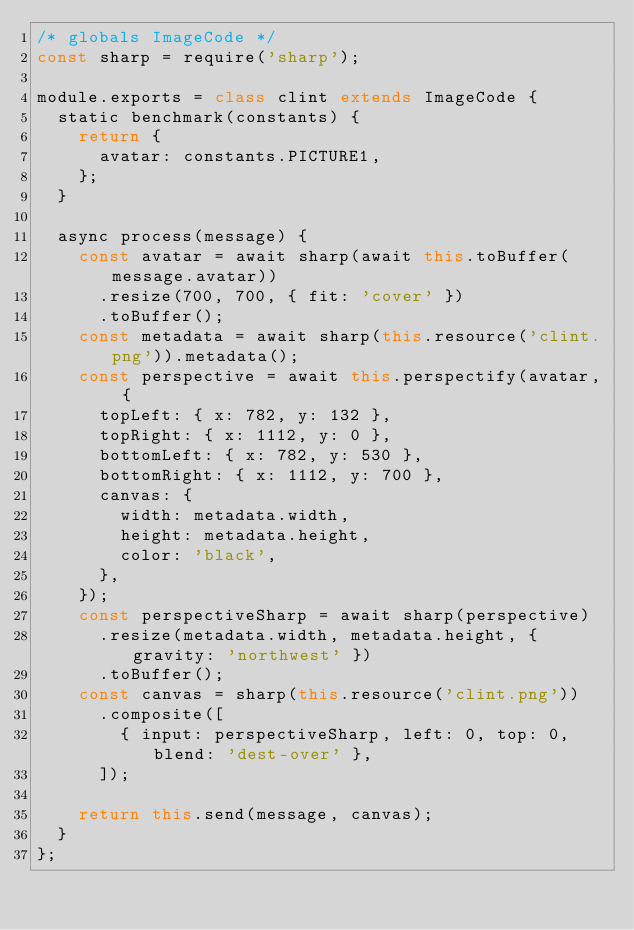Convert code to text. <code><loc_0><loc_0><loc_500><loc_500><_JavaScript_>/* globals ImageCode */
const sharp = require('sharp');

module.exports = class clint extends ImageCode {
  static benchmark(constants) {
    return {
      avatar: constants.PICTURE1,
    };
  }

  async process(message) {
    const avatar = await sharp(await this.toBuffer(message.avatar))
      .resize(700, 700, { fit: 'cover' })
      .toBuffer();
    const metadata = await sharp(this.resource('clint.png')).metadata();
    const perspective = await this.perspectify(avatar, {
      topLeft: { x: 782, y: 132 },
      topRight: { x: 1112, y: 0 },
      bottomLeft: { x: 782, y: 530 },
      bottomRight: { x: 1112, y: 700 },
      canvas: {
        width: metadata.width,
        height: metadata.height,
        color: 'black',
      },
    });
    const perspectiveSharp = await sharp(perspective)
      .resize(metadata.width, metadata.height, { gravity: 'northwest' })
      .toBuffer();
    const canvas = sharp(this.resource('clint.png'))
      .composite([
        { input: perspectiveSharp, left: 0, top: 0, blend: 'dest-over' },
      ]);

    return this.send(message, canvas);
  }
};</code> 